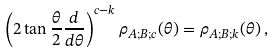<formula> <loc_0><loc_0><loc_500><loc_500>\left ( 2 \tan \frac { \theta } { 2 } \frac { d } { d \theta } \right ) ^ { c - k } \rho _ { A ; B ; c } ( \theta ) = \rho _ { A ; B ; k } ( \theta ) \, ,</formula> 